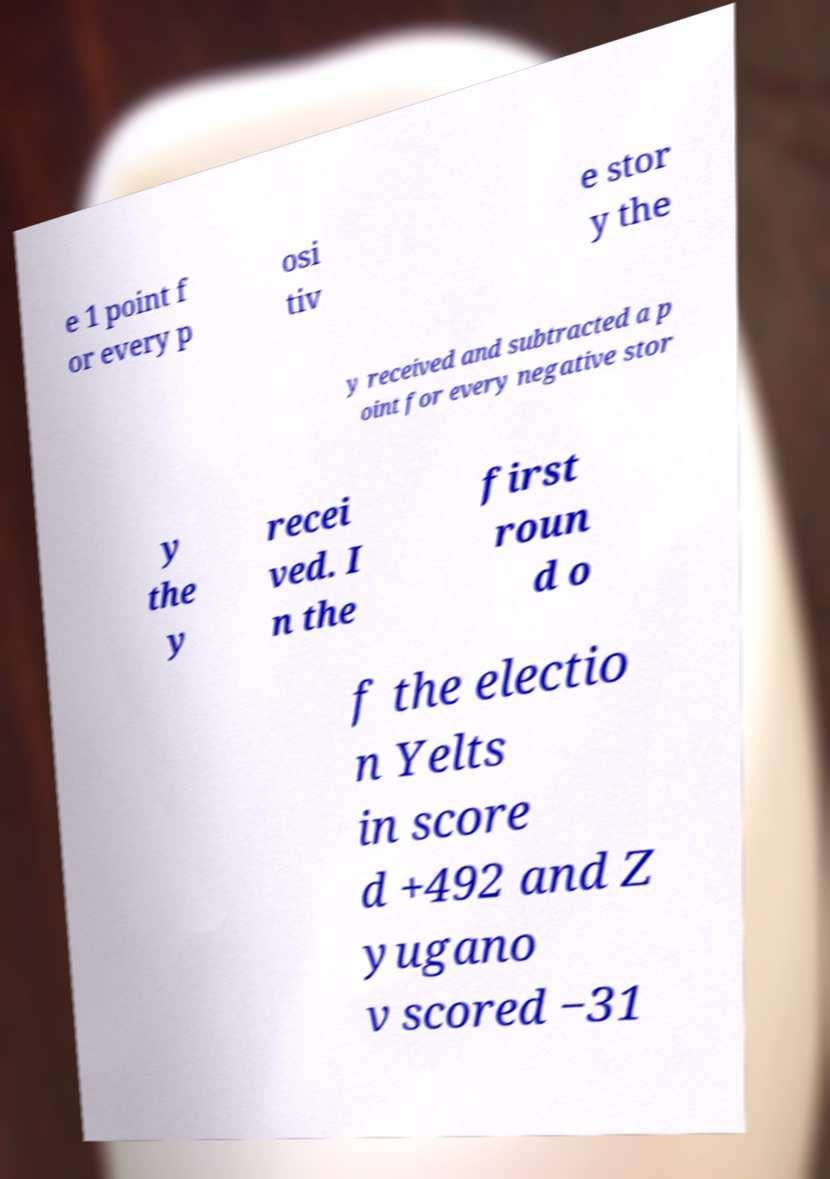Could you extract and type out the text from this image? e 1 point f or every p osi tiv e stor y the y received and subtracted a p oint for every negative stor y the y recei ved. I n the first roun d o f the electio n Yelts in score d +492 and Z yugano v scored −31 